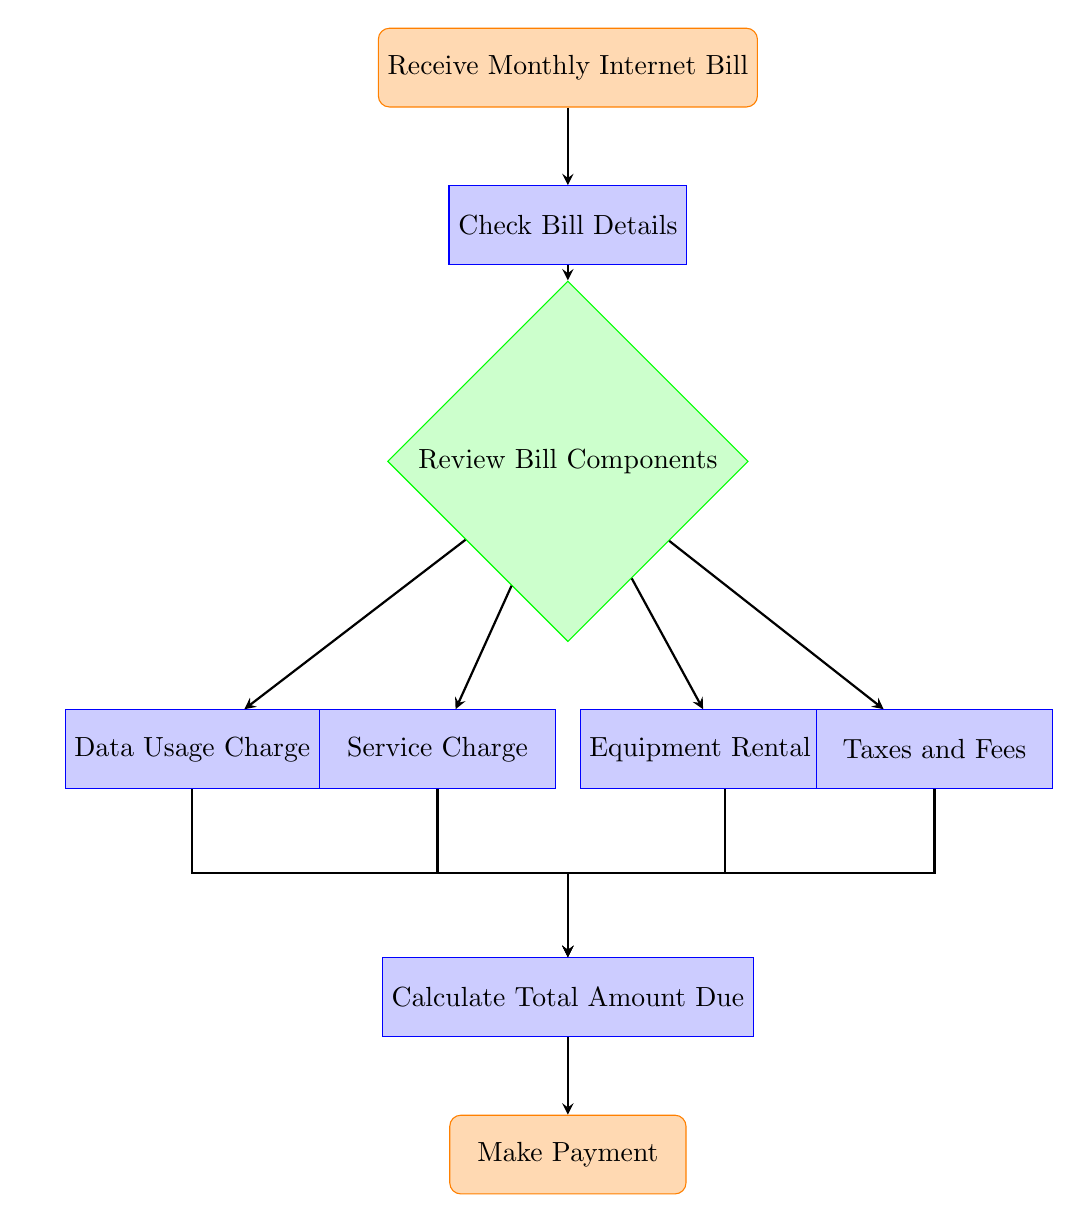What is the starting point of the flow chart? The flow chart starts with the node labeled "Receive Monthly Internet Bill." This can be found at the top of the diagram as the first action to be taken.
Answer: Receive Monthly Internet Bill How many components need to be reviewed after checking the bill? After checking the bill details, the next step is to review the components, which indicates that there is only one action to take in that node.
Answer: One What are the processes involved in calculating the total amount due? The processes involved in calculating the total amount due include "Service Charge," "Data Usage Charge," "Equipment Rental Fee," and "Taxes and Fees." All these processes lead into the "Calculate Total Amount Due" node.
Answer: Service Charge, Data Usage Charge, Equipment Rental Fee, Taxes and Fees What happens if no service charge exists? If there is no service charge, the flow continues from the "components" node to the next existing charges, such as "Data Usage Charge," "Equipment Rental Fee," or "Taxes and Fees," before proceeding to calculate the total amount.
Answer: Continue to next existing charges How many nodes lead to the total amount due? There are four nodes leading to the "Calculate Total Amount Due": "Service Charge," "Data Usage Charge," "Equipment Rental Fee," and "Taxes and Fees." Each of these processes must be computed for the total amount.
Answer: Four 